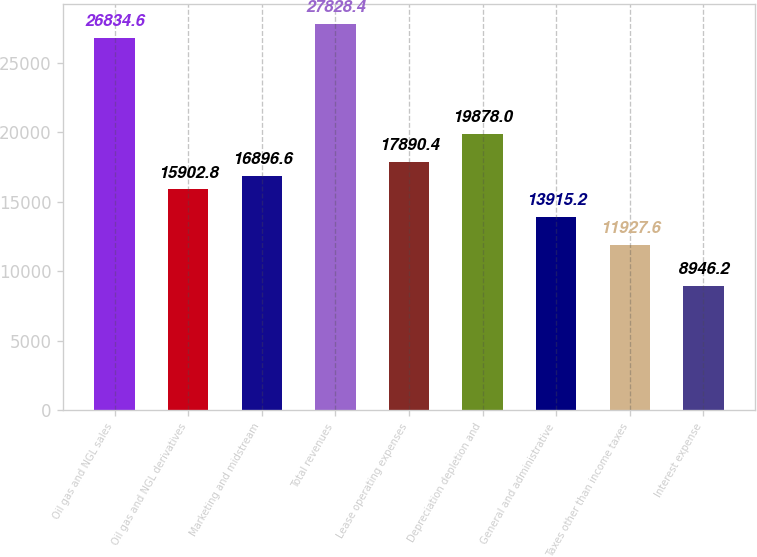Convert chart. <chart><loc_0><loc_0><loc_500><loc_500><bar_chart><fcel>Oil gas and NGL sales<fcel>Oil gas and NGL derivatives<fcel>Marketing and midstream<fcel>Total revenues<fcel>Lease operating expenses<fcel>Depreciation depletion and<fcel>General and administrative<fcel>Taxes other than income taxes<fcel>Interest expense<nl><fcel>26834.6<fcel>15902.8<fcel>16896.6<fcel>27828.4<fcel>17890.4<fcel>19878<fcel>13915.2<fcel>11927.6<fcel>8946.2<nl></chart> 